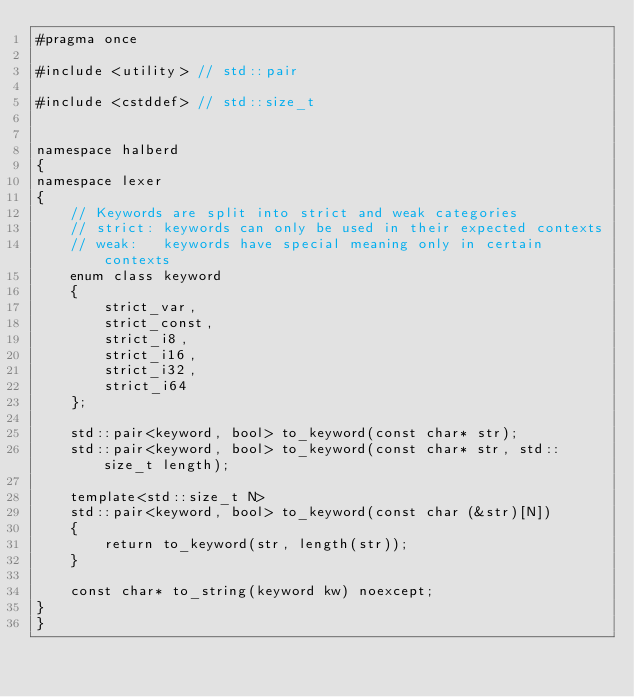<code> <loc_0><loc_0><loc_500><loc_500><_C_>#pragma once

#include <utility> // std::pair

#include <cstddef> // std::size_t


namespace halberd
{
namespace lexer
{
    // Keywords are split into strict and weak categories
    // strict: keywords can only be used in their expected contexts
    // weak:   keywords have special meaning only in certain contexts
    enum class keyword
    {
        strict_var,
        strict_const,
        strict_i8,
        strict_i16,
        strict_i32,
        strict_i64
    };

    std::pair<keyword, bool> to_keyword(const char* str);
    std::pair<keyword, bool> to_keyword(const char* str, std::size_t length);

    template<std::size_t N>
    std::pair<keyword, bool> to_keyword(const char (&str)[N])
    {
        return to_keyword(str, length(str));
    }

    const char* to_string(keyword kw) noexcept;
}
}
</code> 